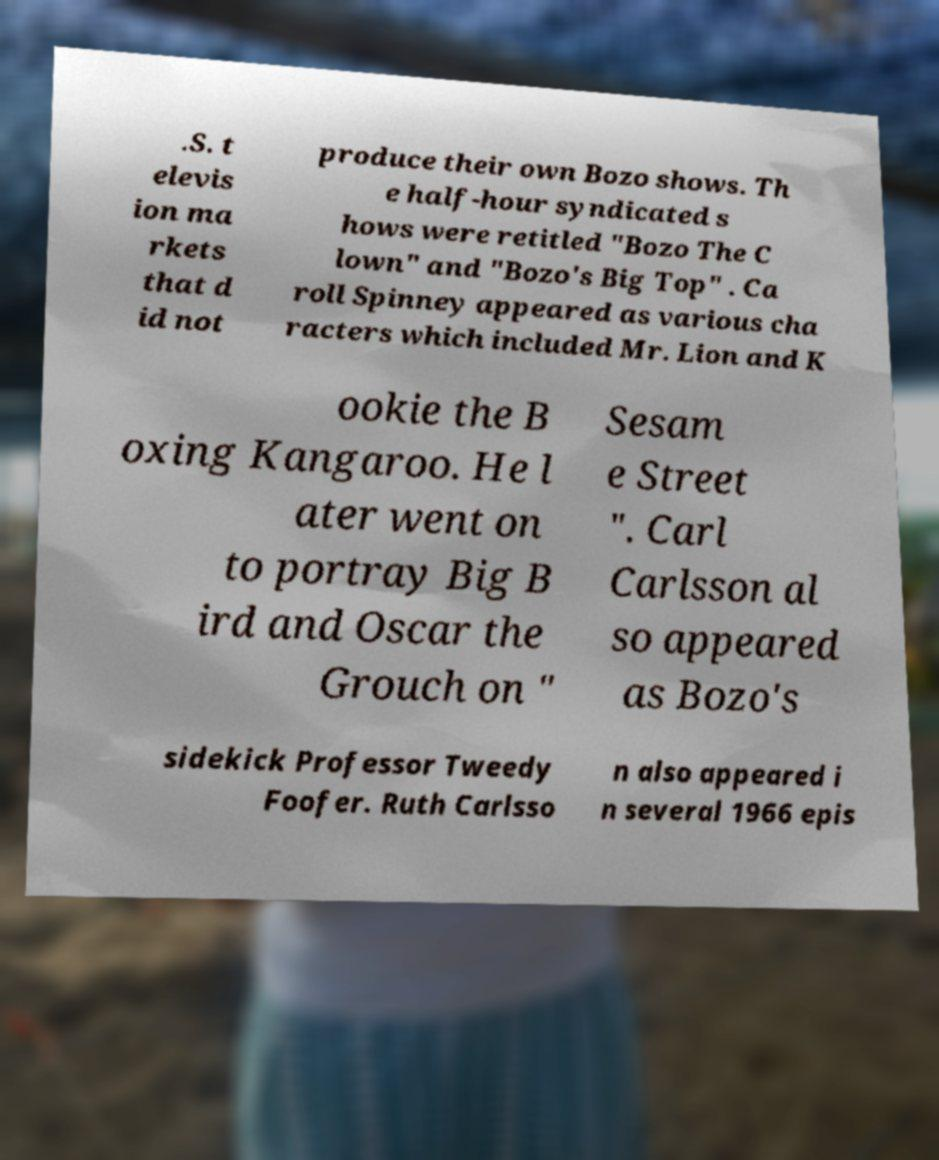What messages or text are displayed in this image? I need them in a readable, typed format. .S. t elevis ion ma rkets that d id not produce their own Bozo shows. Th e half-hour syndicated s hows were retitled "Bozo The C lown" and "Bozo's Big Top" . Ca roll Spinney appeared as various cha racters which included Mr. Lion and K ookie the B oxing Kangaroo. He l ater went on to portray Big B ird and Oscar the Grouch on " Sesam e Street ". Carl Carlsson al so appeared as Bozo's sidekick Professor Tweedy Foofer. Ruth Carlsso n also appeared i n several 1966 epis 